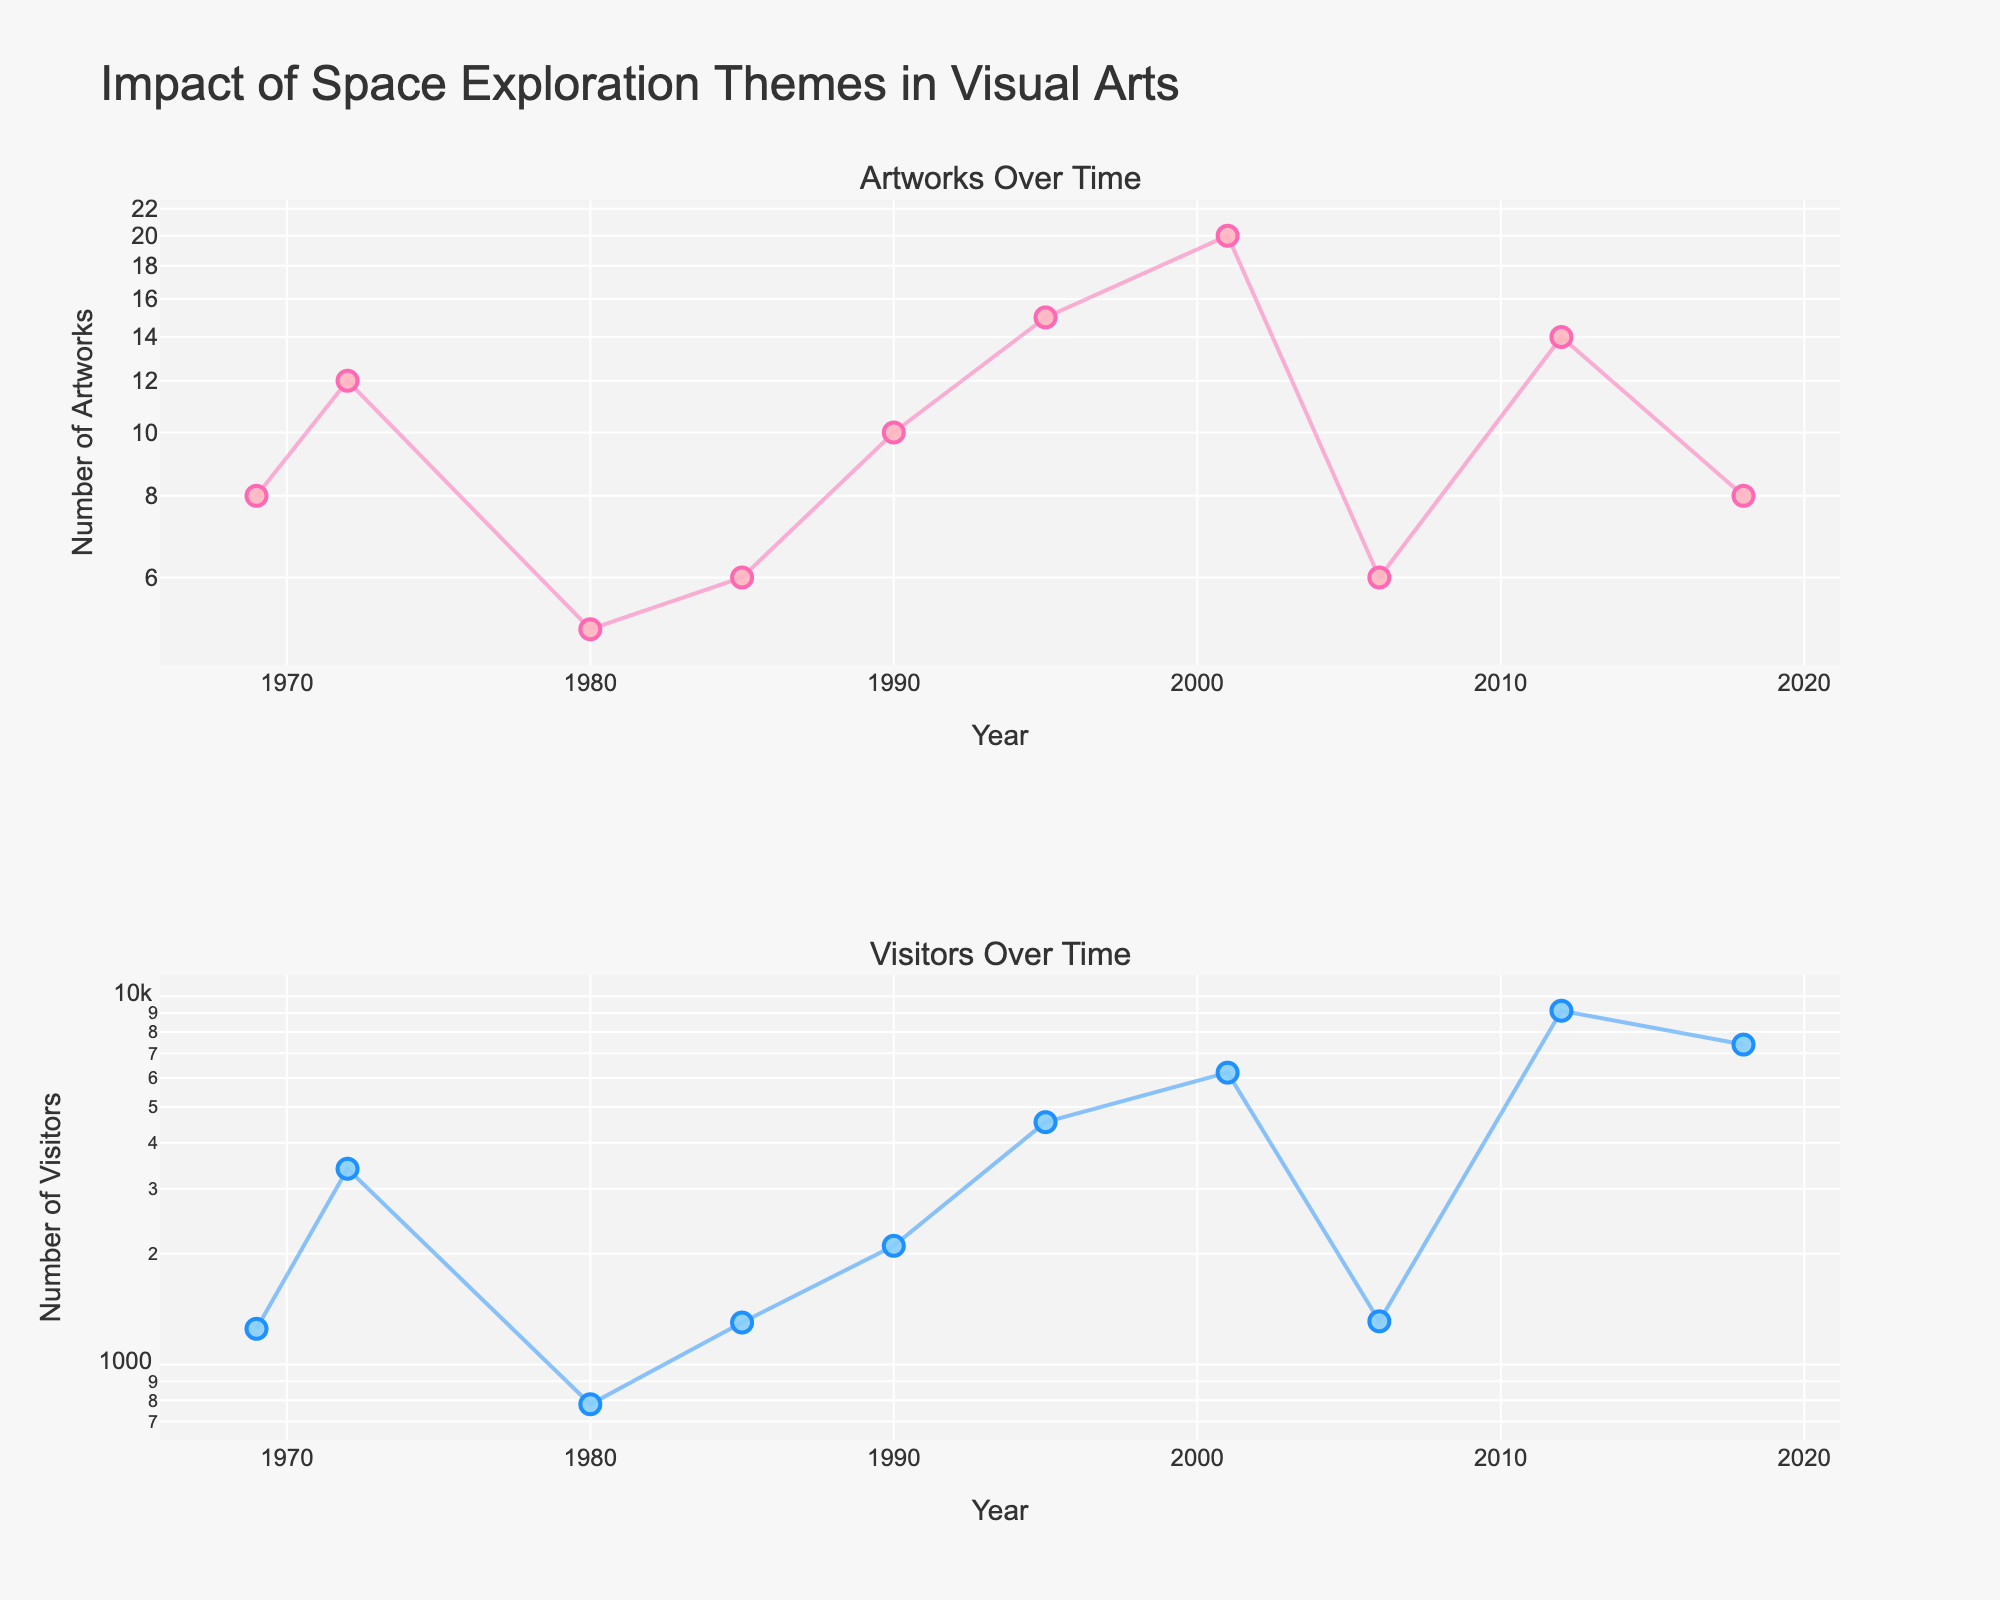What is the title of the plot? The title of the plot is displayed at the top of the figure. It reads "Impact of Space Exploration Themes in Visual Arts".
Answer: Impact of Space Exploration Themes in Visual Arts How many data points are there in the first subplot? There is one data point for each year in the first subplot, which means there are as many data points as there are unique years listed in the data table. There are 10 unique years.
Answer: 10 What is the y-axis title for the second subplot? The y-axis title for the second subplot is located vertically on the left side of the second subplot. It reads "Number of Visitors".
Answer: Number of Visitors How does the number of artworks change over time? The number of artworks in the figure is represented by markers and lines in the first subplot. By following the trend from left to right (1969 to 2018), we can see that the number of artworks generally increases over time with some fluctuations.
Answer: Increases Which exhibition had the highest number of visitors? The highest number of visitors is represented by the tallest point in the log-scaled second subplot. By referring to the hover information for that point, we find it is the 2012 "Space Program: Mars" exhibition by Tom Sachs, with 9130 visitors.
Answer: Space Program: Mars (Tom Sachs, 2012) Compare the number of artworks and visitors for the "Moon Museum Exhibit" and "Orbital Reflector". Which exhibition had more artworks, and which had more visitors? To answer this, compare the data points for the years 1969 (Moon Museum Exhibit) and 2018 (Orbital Reflector) in both subplots. "Orbital Reflector" had 8 artworks and 7390 visitors, while "Moon Museum Exhibit" had 8 artworks but only 1250 visitors. Hence, both had the same number of artworks, but "Orbital Reflector" had more visitors.
Answer: Same number of artworks, Orbital Reflector had more visitors What is the range of the visitors' numbers in the second subplot? The range can be found by subtracting the minimum number of visitors from the maximum number of visitors in the second subplot. The minimum is around 780 and the maximum is 9130. Therefore, 9130 - 780 = 8350.
Answer: 8350 Between which years did we see the highest increase in the number of visitors? To find the highest increase, check the visitors for each consecutive year in the second subplot and calculate the differences. The highest increase appears between 2006 (1310 visitors) and 2012 (9130 visitors). The difference is 9130 - 1310 = 7820.
Answer: Between 2006 and 2012 Which artist has exhibited the highest total number of artworks over the years, based on the data provided? Sum the number of artworks for each artist. From the hover information and table, Nam June Paik has 15 artworks, Olafur Eliasson has 20 artworks, and Tom Sachs has 14 artworks. Therefore, Olafur Eliasson has exhibited the highest total number of artworks.
Answer: Olafur Eliasson 